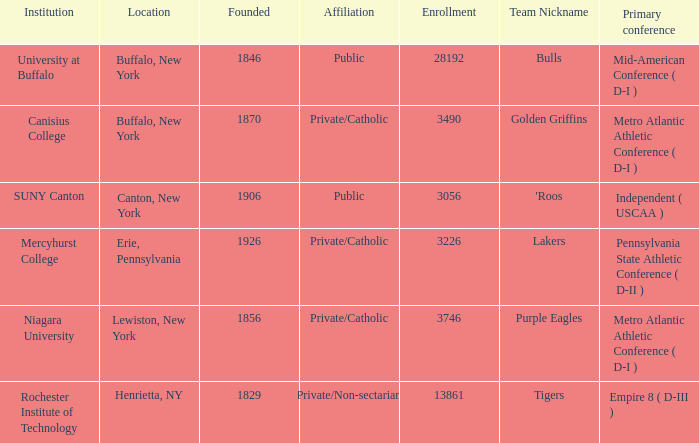What was the enrollment of the school founded in 1846? 28192.0. 